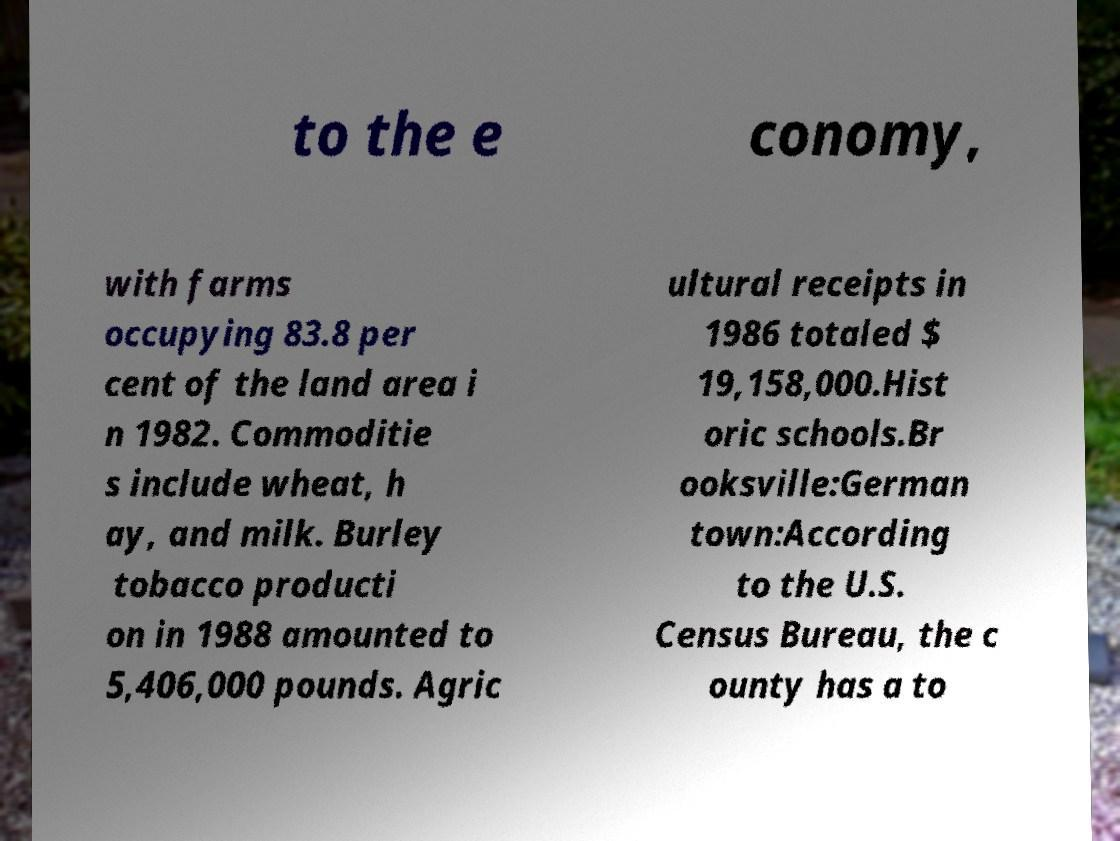Please read and relay the text visible in this image. What does it say? to the e conomy, with farms occupying 83.8 per cent of the land area i n 1982. Commoditie s include wheat, h ay, and milk. Burley tobacco producti on in 1988 amounted to 5,406,000 pounds. Agric ultural receipts in 1986 totaled $ 19,158,000.Hist oric schools.Br ooksville:German town:According to the U.S. Census Bureau, the c ounty has a to 